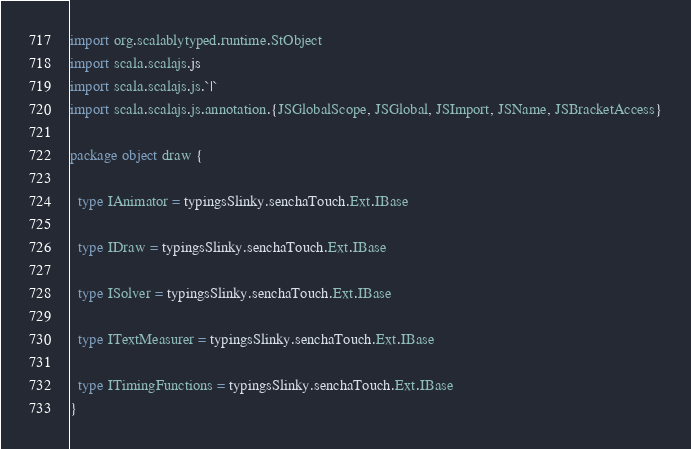Convert code to text. <code><loc_0><loc_0><loc_500><loc_500><_Scala_>
import org.scalablytyped.runtime.StObject
import scala.scalajs.js
import scala.scalajs.js.`|`
import scala.scalajs.js.annotation.{JSGlobalScope, JSGlobal, JSImport, JSName, JSBracketAccess}

package object draw {
  
  type IAnimator = typingsSlinky.senchaTouch.Ext.IBase
  
  type IDraw = typingsSlinky.senchaTouch.Ext.IBase
  
  type ISolver = typingsSlinky.senchaTouch.Ext.IBase
  
  type ITextMeasurer = typingsSlinky.senchaTouch.Ext.IBase
  
  type ITimingFunctions = typingsSlinky.senchaTouch.Ext.IBase
}
</code> 